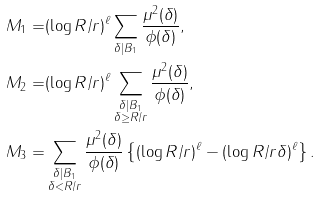<formula> <loc_0><loc_0><loc_500><loc_500>M _ { 1 } = & ( \log R / r ) ^ { \ell } \sum _ { \delta | B _ { 1 } } \frac { \mu ^ { 2 } ( \delta ) } { \phi ( \delta ) } , \\ M _ { 2 } = & ( \log R / r ) ^ { \ell } \sum _ { \substack { \delta | B _ { 1 } \\ \delta \geq R / r } } \frac { \mu ^ { 2 } ( \delta ) } { \phi ( \delta ) } , \\ M _ { 3 } = & \sum _ { \substack { \delta | B _ { 1 } \\ \delta < R / r } } \frac { \mu ^ { 2 } ( \delta ) } { \phi ( \delta ) } \left \{ ( \log R / r ) ^ { \ell } - ( \log R / r \delta ) ^ { \ell } \right \} .</formula> 